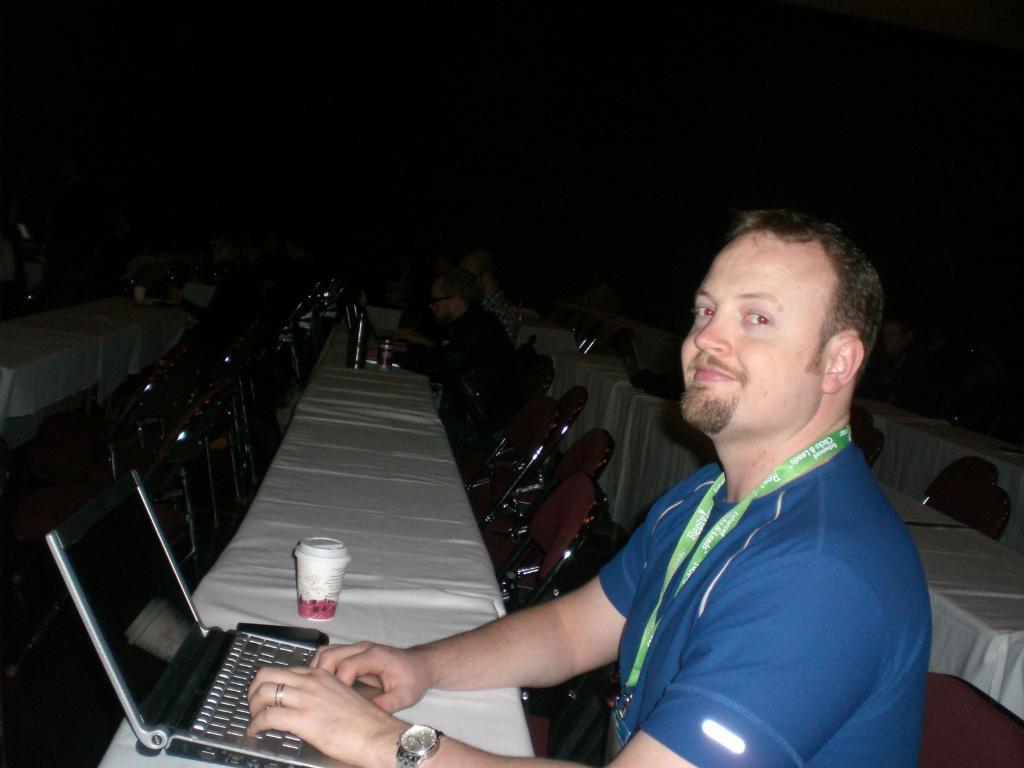Could you give a brief overview of what you see in this image? In this image there is a person wearing blue shirt and there is a laptop in the foreground. There are chairs, people, tables with objects on them in the background. 